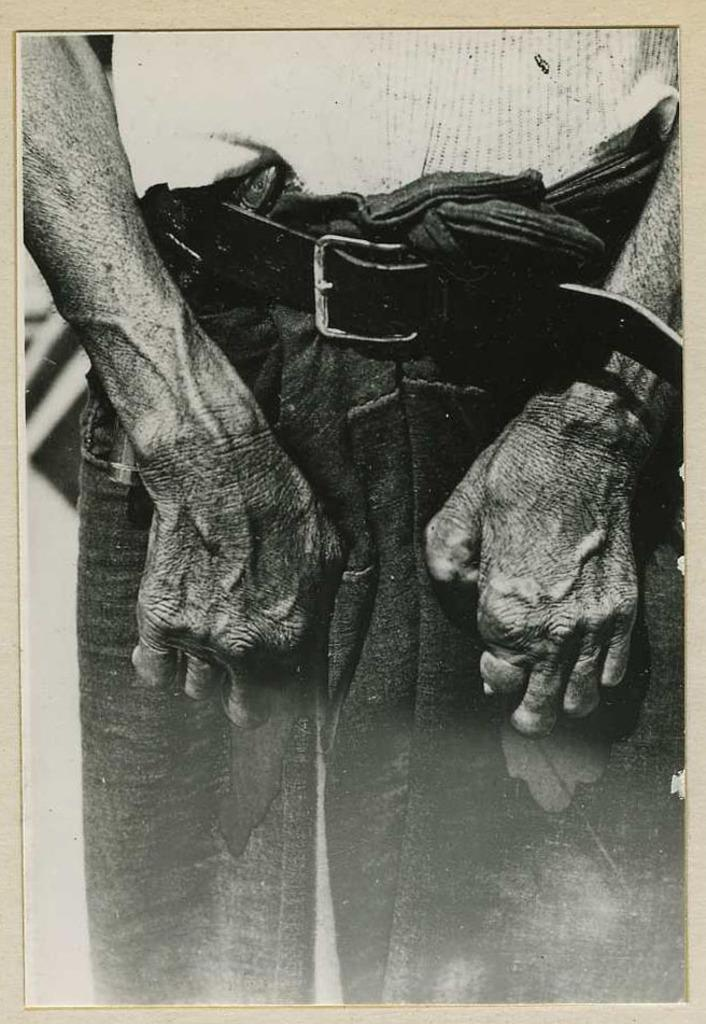What is the color scheme of the image? The image is black and white. Can you describe the person in the image? The person in the image is wearing a shirt, pants, and a belt. How many units of zebras can be seen in the image? There are no zebras present in the image. 